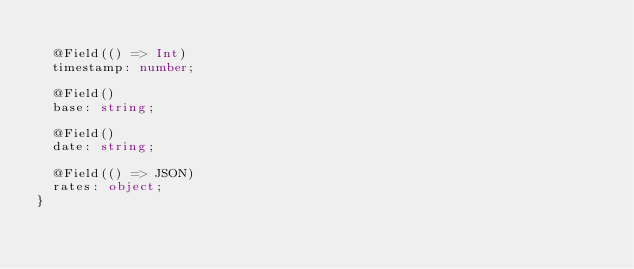Convert code to text. <code><loc_0><loc_0><loc_500><loc_500><_TypeScript_>
  @Field(() => Int)
  timestamp: number;

  @Field()
  base: string;

  @Field()
  date: string;

  @Field(() => JSON)
  rates: object;
}
</code> 